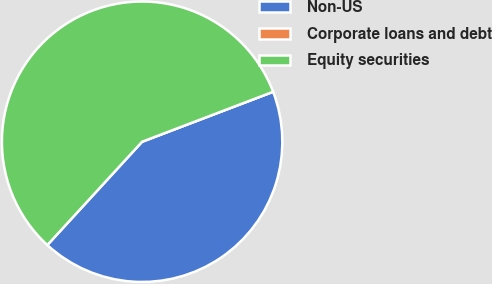Convert chart. <chart><loc_0><loc_0><loc_500><loc_500><pie_chart><fcel>Non-US<fcel>Corporate loans and debt<fcel>Equity securities<nl><fcel>42.61%<fcel>0.0%<fcel>57.38%<nl></chart> 